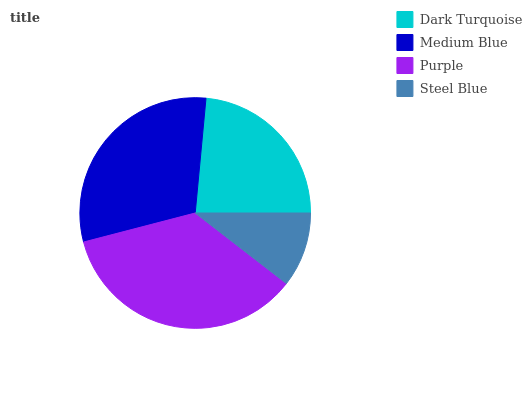Is Steel Blue the minimum?
Answer yes or no. Yes. Is Purple the maximum?
Answer yes or no. Yes. Is Medium Blue the minimum?
Answer yes or no. No. Is Medium Blue the maximum?
Answer yes or no. No. Is Medium Blue greater than Dark Turquoise?
Answer yes or no. Yes. Is Dark Turquoise less than Medium Blue?
Answer yes or no. Yes. Is Dark Turquoise greater than Medium Blue?
Answer yes or no. No. Is Medium Blue less than Dark Turquoise?
Answer yes or no. No. Is Medium Blue the high median?
Answer yes or no. Yes. Is Dark Turquoise the low median?
Answer yes or no. Yes. Is Steel Blue the high median?
Answer yes or no. No. Is Steel Blue the low median?
Answer yes or no. No. 